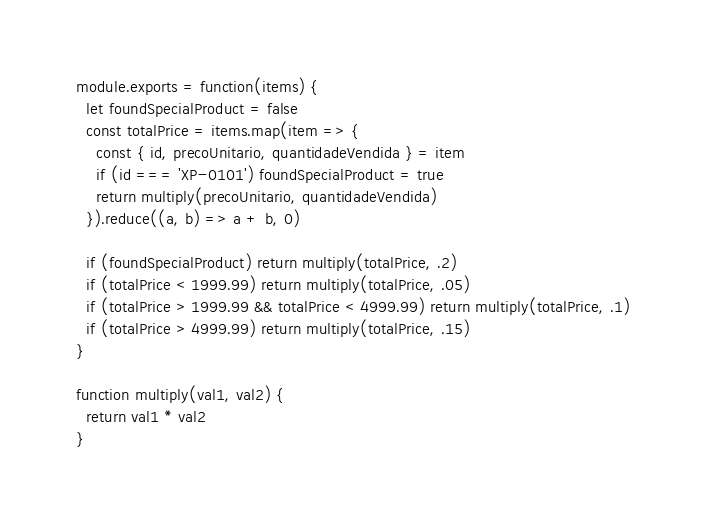<code> <loc_0><loc_0><loc_500><loc_500><_JavaScript_>module.exports = function(items) {
  let foundSpecialProduct = false
  const totalPrice = items.map(item => {
    const { id, precoUnitario, quantidadeVendida } = item
    if (id === 'XP-0101') foundSpecialProduct = true
    return multiply(precoUnitario, quantidadeVendida)
  }).reduce((a, b) => a + b, 0)

  if (foundSpecialProduct) return multiply(totalPrice, .2)
  if (totalPrice < 1999.99) return multiply(totalPrice, .05)
  if (totalPrice > 1999.99 && totalPrice < 4999.99) return multiply(totalPrice, .1)
  if (totalPrice > 4999.99) return multiply(totalPrice, .15)
}

function multiply(val1, val2) {
  return val1 * val2
}
</code> 